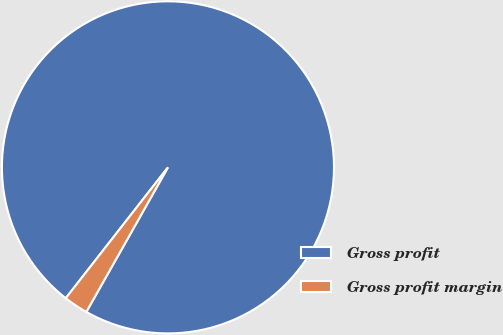Convert chart. <chart><loc_0><loc_0><loc_500><loc_500><pie_chart><fcel>Gross profit<fcel>Gross profit margin<nl><fcel>97.63%<fcel>2.37%<nl></chart> 